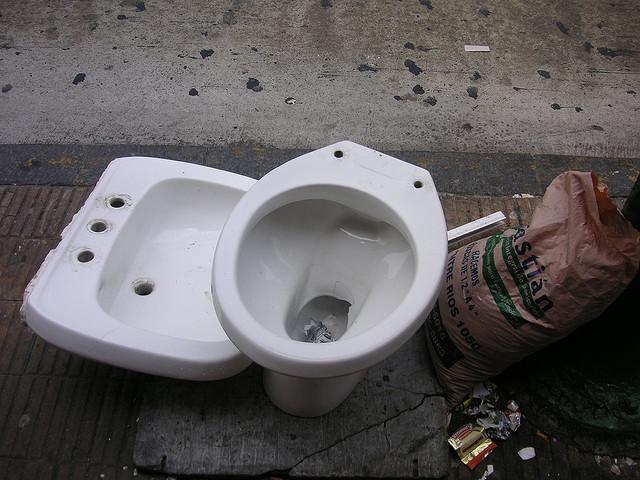What is on the curb?
Write a very short answer. Toilet. In what room would you generally find these items?
Give a very brief answer. Bathroom. Is this a city street?
Short answer required. Yes. 